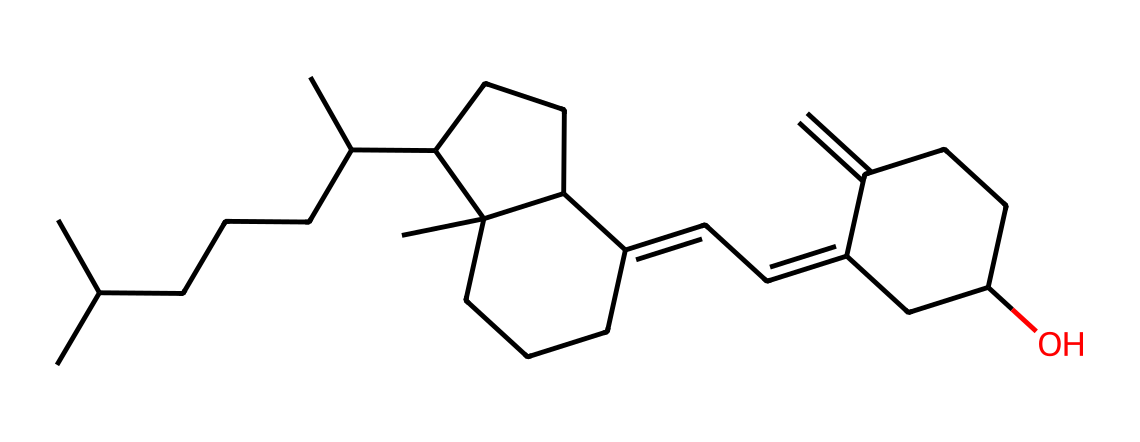What is the primary molecular component of Vitamin D? The SMILES representation indicates the presence of carbon atoms predominantly in the structure, which suggests it is a hydrocarbon. Vitamin D is specifically known to be a compound that belongs to the steroid family, which mainly consists of carbon.
Answer: carbon How many carbon atoms are present in this structure? To determine the number of carbon atoms, we can count each 'C' in the SMILES notation. Upon counting, there are 27 carbon atoms in total.
Answer: 27 What class of vitamin does this structure represent? The chemical structure indicates that it contains a cyclopentane ring and multiple fused rings, aligning with characteristics of fat-soluble vitamins. Vitamin D falls under the category of fat-soluble vitamins.
Answer: fat-soluble What functional groups are present in this molecule? Analyzing the structure, we can identify a hydroxyl (-OH) group represented at the end of one of the carbon chains that confirms the presence of a specific functional group, indicative of an alcohol.
Answer: hydroxyl group How does this molecular composition contribute to immune support? The presence of Vitamin D in the molecular structure indicates its role in modulating the immune system by promoting the expression of genes involved in immune responses. Due to its structural features, such as lipid solubility, it enhances the absorption of essential nutrients supportive of immune health.
Answer: enhanced immune response 